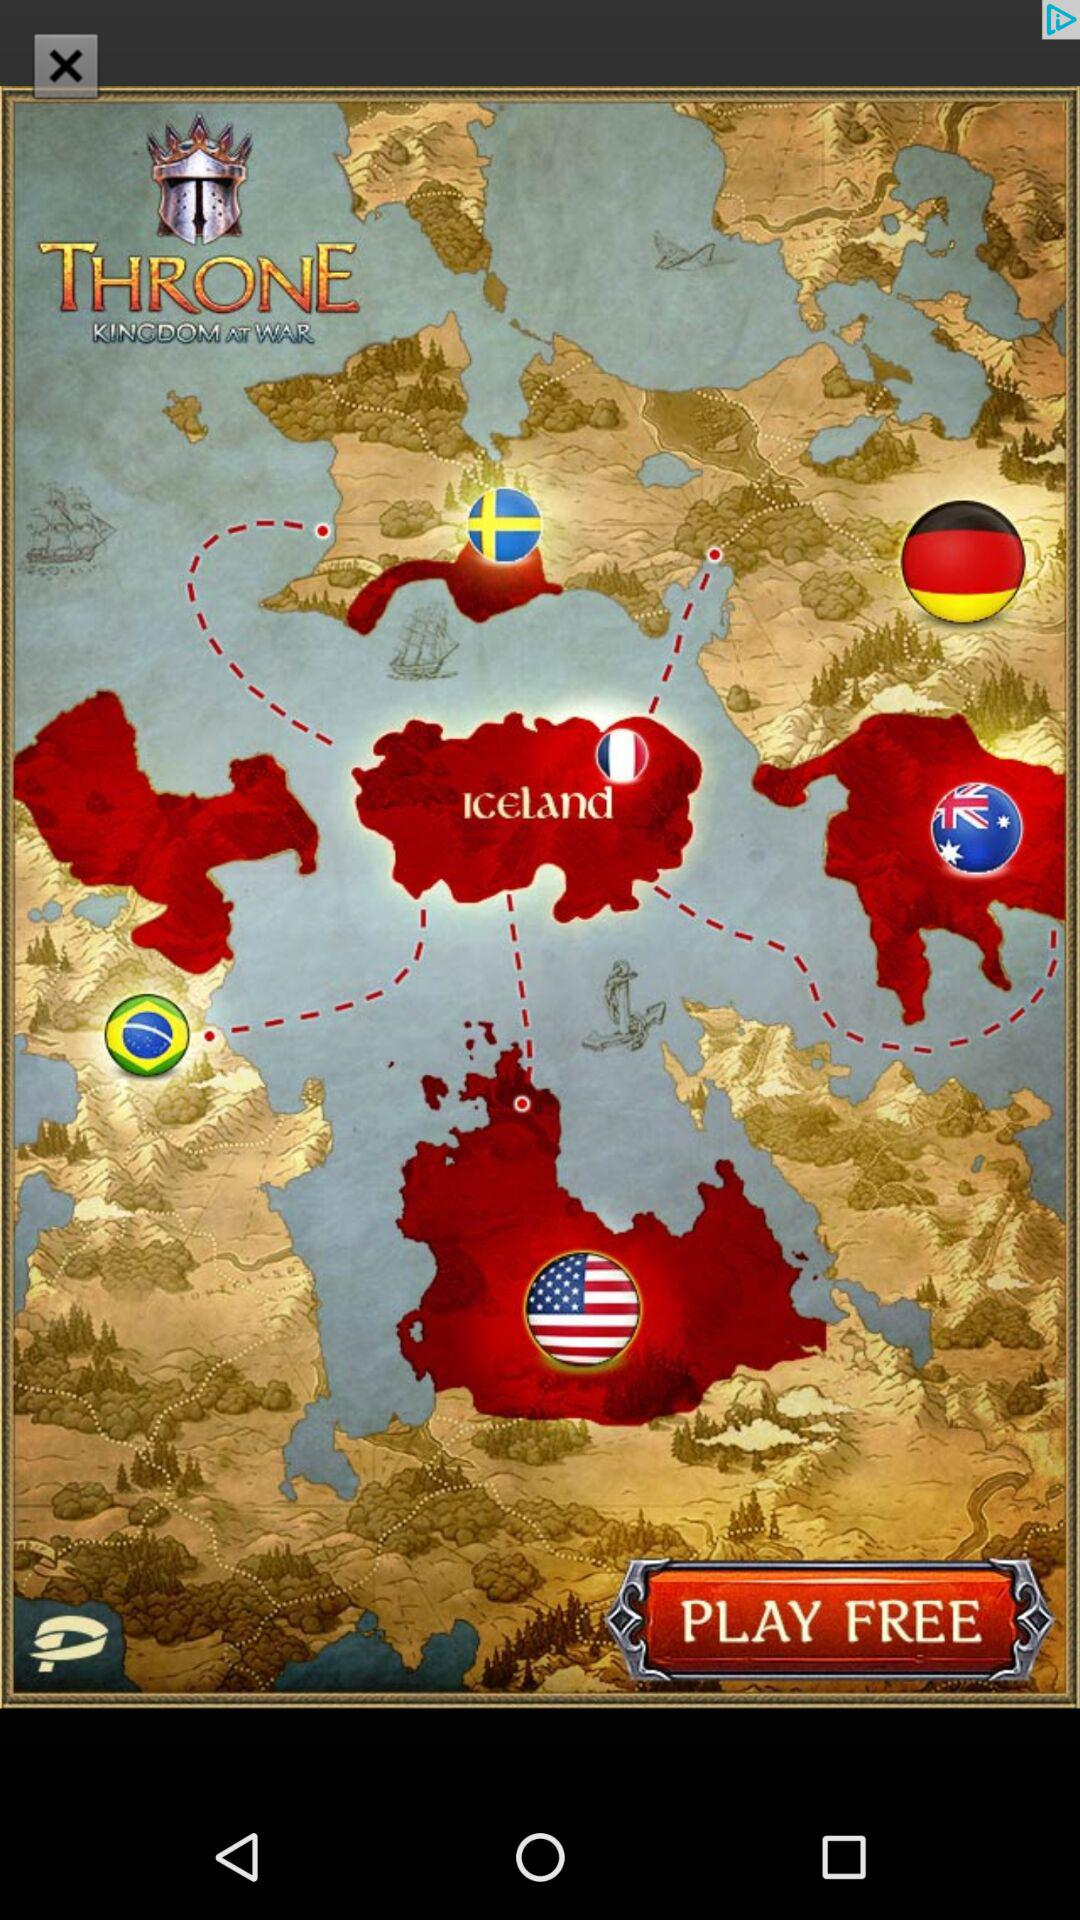What is the application name? The application name is "THRONE KINGDOM AT WAR". 